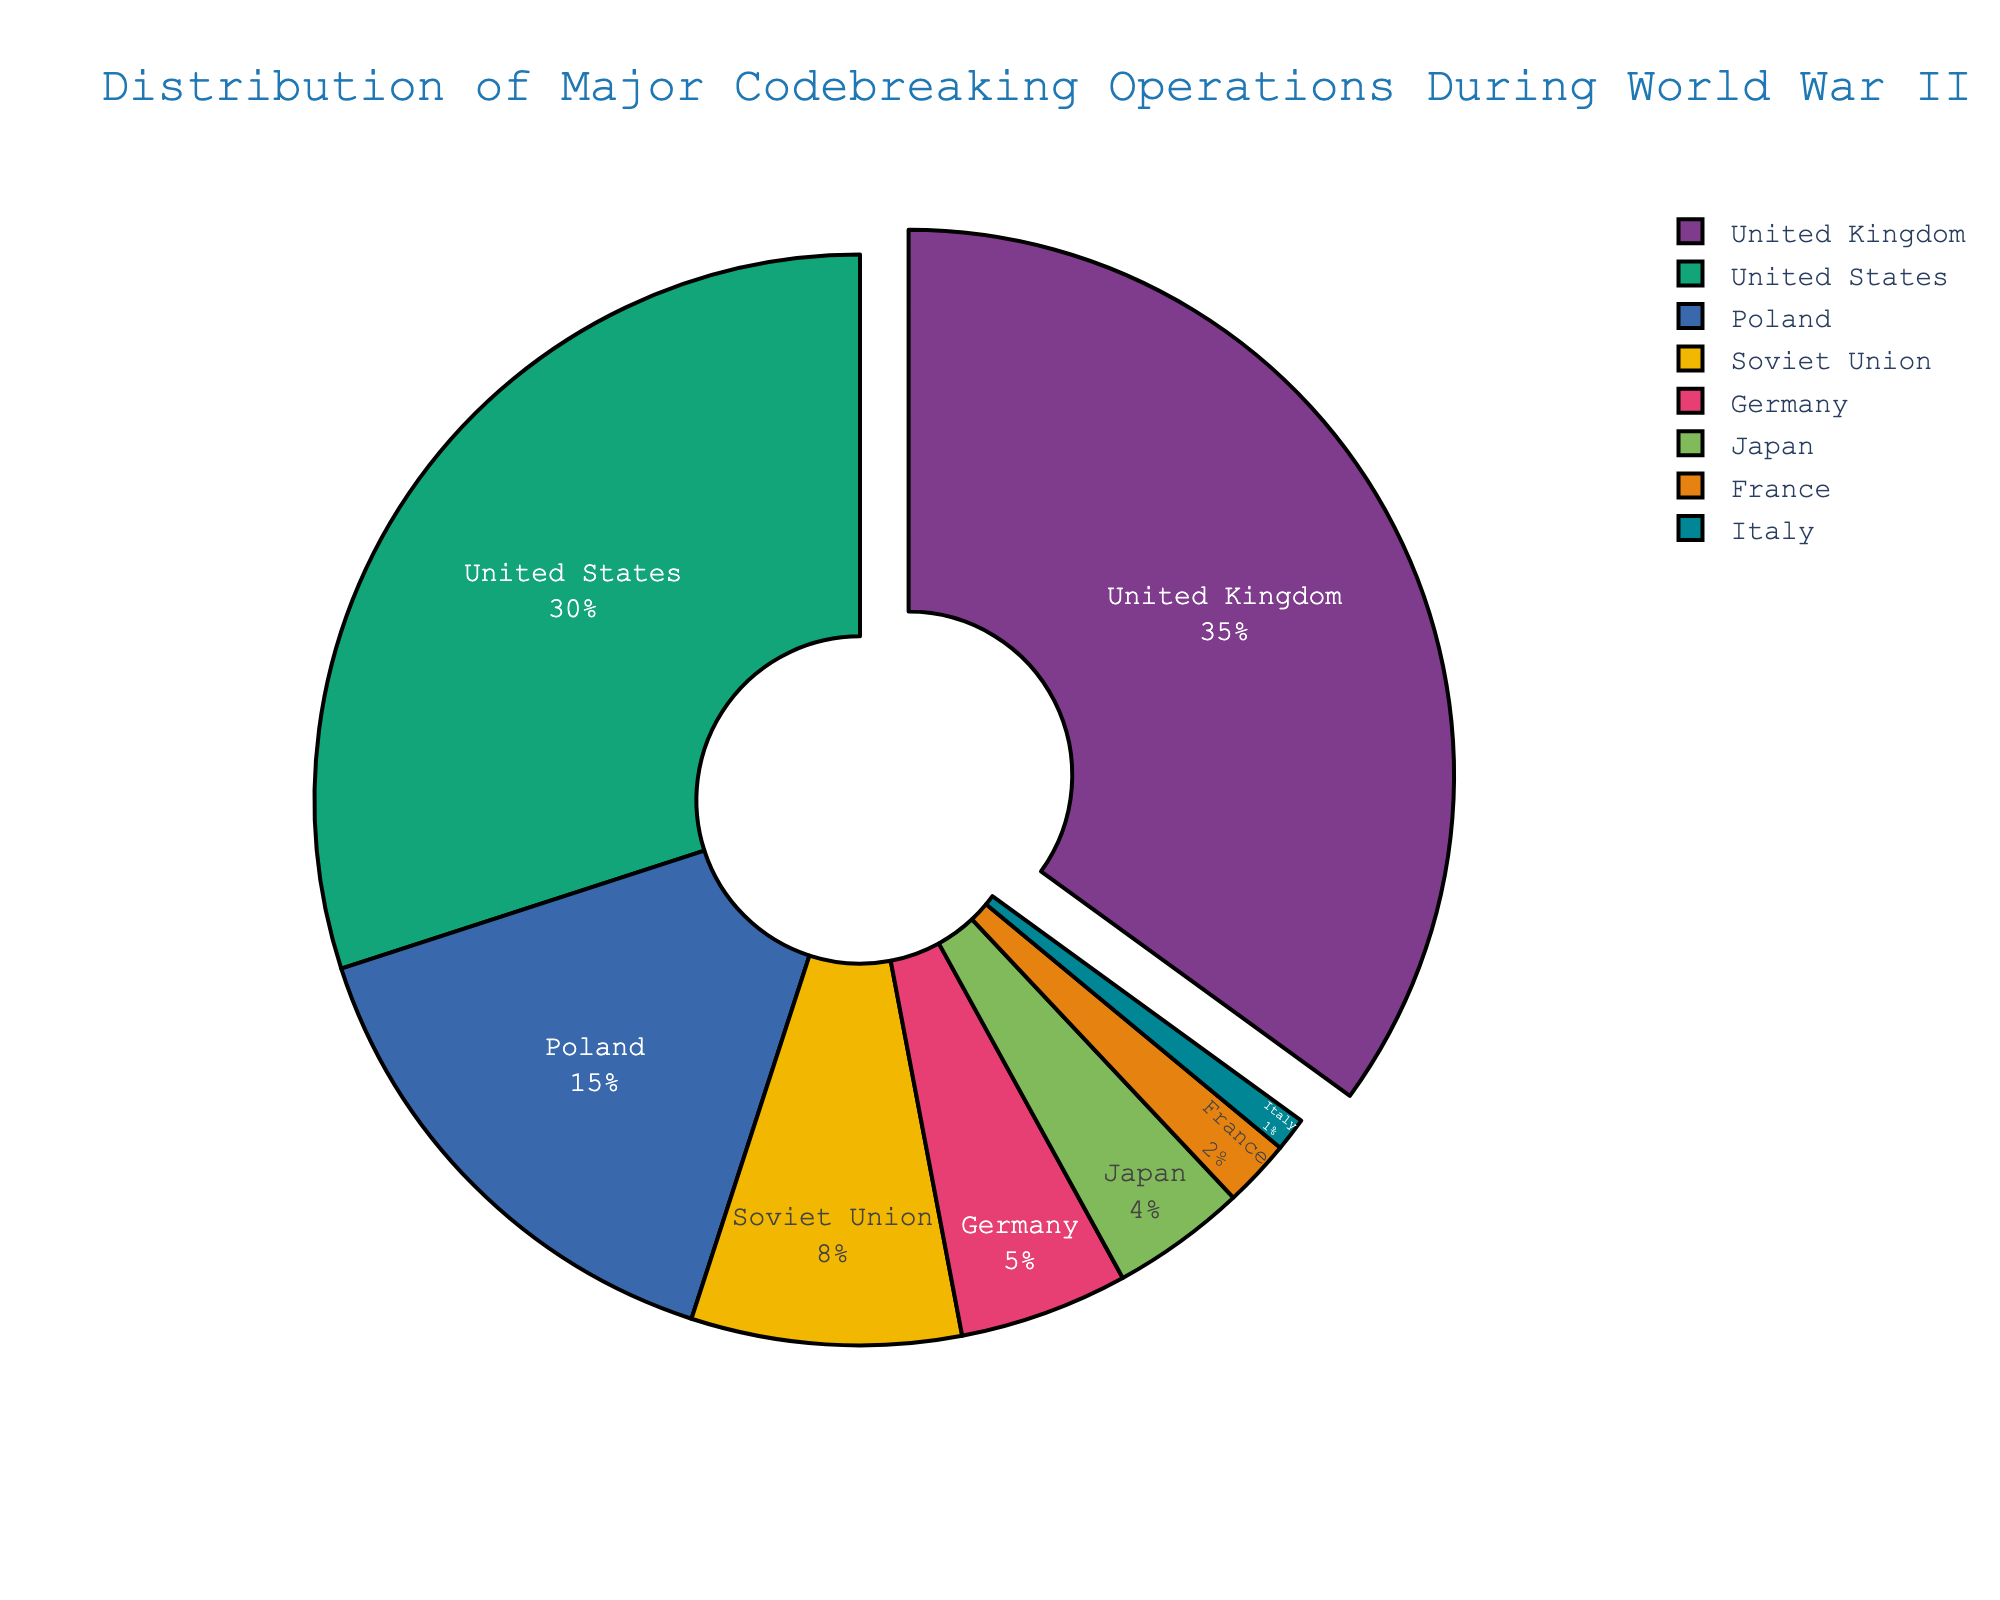Which country has the highest percentage of major codebreaking operations during World War II? The United Kingdom has the highest percentage. This can be seen because it occupies the largest portion of the pie chart, with 35%.
Answer: United Kingdom How much greater is the percentage of codebreaking operations conducted by the United Kingdom compared to Germany? The United Kingdom's percentage is 35% and Germany's is 5%. The difference is calculated by subtracting Germany's percentage from the United Kingdom's: 35% - 5% = 30%.
Answer: 30% Which countries together contribute to more than 50% of the major codebreaking operations? The United Kingdom contributes 35% and the United States contributes 30%. Together, they make up 35% + 30% = 65%, which is more than 50%.
Answer: United Kingdom and United States What is the combined percentage of codebreaking operations conducted by Poland, the Soviet Union, and Japan? Adding the percentages: Poland (15%) + Soviet Union (8%) + Japan (4%) = 15% + 8% + 4% = 27%.
Answer: 27% Which countries have less than 5% of the total codebreaking operations? The pie chart shows that France (2%), Italy (1%), Germany (5%), and Japan (4%) are represented. Among these, France, Italy, and Japan have less than 5%.
Answer: France, Italy, Japan How does the United States' percentage compare to that of the Soviet Union? The United States has 30% and the Soviet Union has 8%. Comparing the two, the United States' percentage is greater.
Answer: United States has a greater percentage What is the difference in percentage between Germany and Japan? Germany has 5% and Japan has 4%. The difference is found by subtracting Japan's percentage from Germany's: 5% - 4% = 1%.
Answer: 1% Which country is represented by the smallest segment in the pie chart, and what is its percentage? The smallest segment represents Italy, which has 1% of the total codebreaking operations.
Answer: Italy, 1% Does any country have exactly double the percentage of the Soviet Union? The Soviet Union has 8%. Doubling this is 16%. None of the countries have exactly 16% based on the data provided.
Answer: No What percentage of codebreaking operations are conducted by the countries with the three smallest contributions? The three smallest contributions are by Italy (1%), France (2%), and Japan (4%). Adding these percentages: 1% + 2% + 4% = 7%.
Answer: 7% 